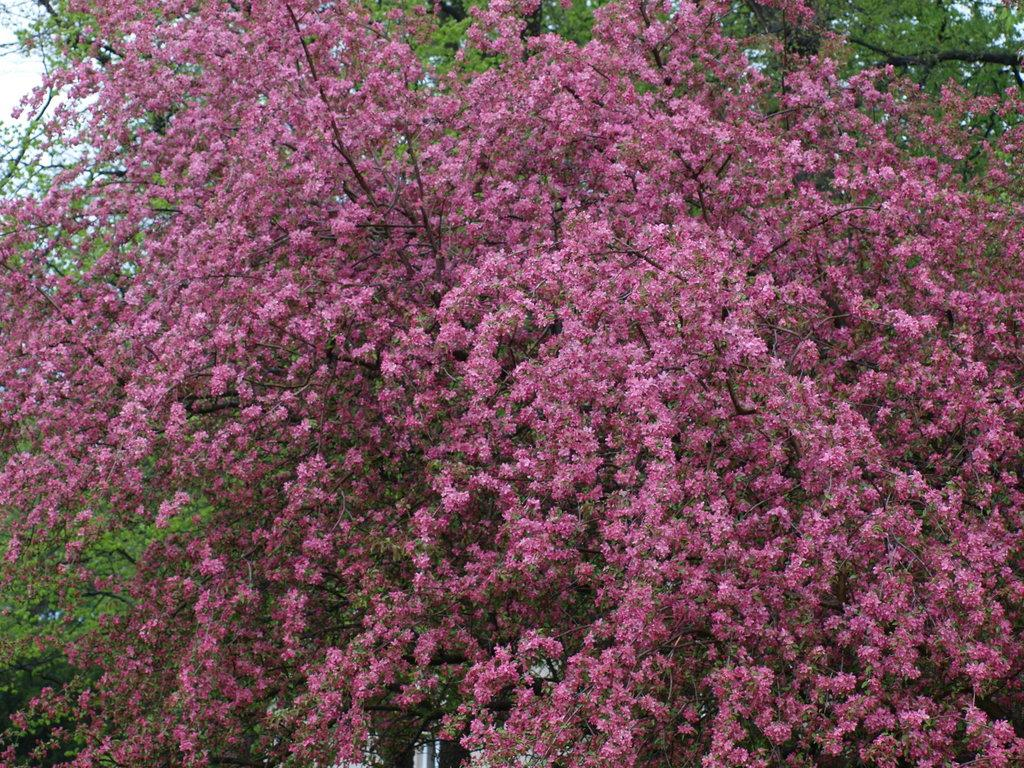What type of tree is present in the image? There is a tree with flowers in the image. What can be seen in the background of the image? There are trees with leaves in the background of the image. What is the afterthought of the birthday celebration in the image? There is no indication of a birthday celebration or any afterthought in the image, as it only features trees with flowers and trees with leaves. 